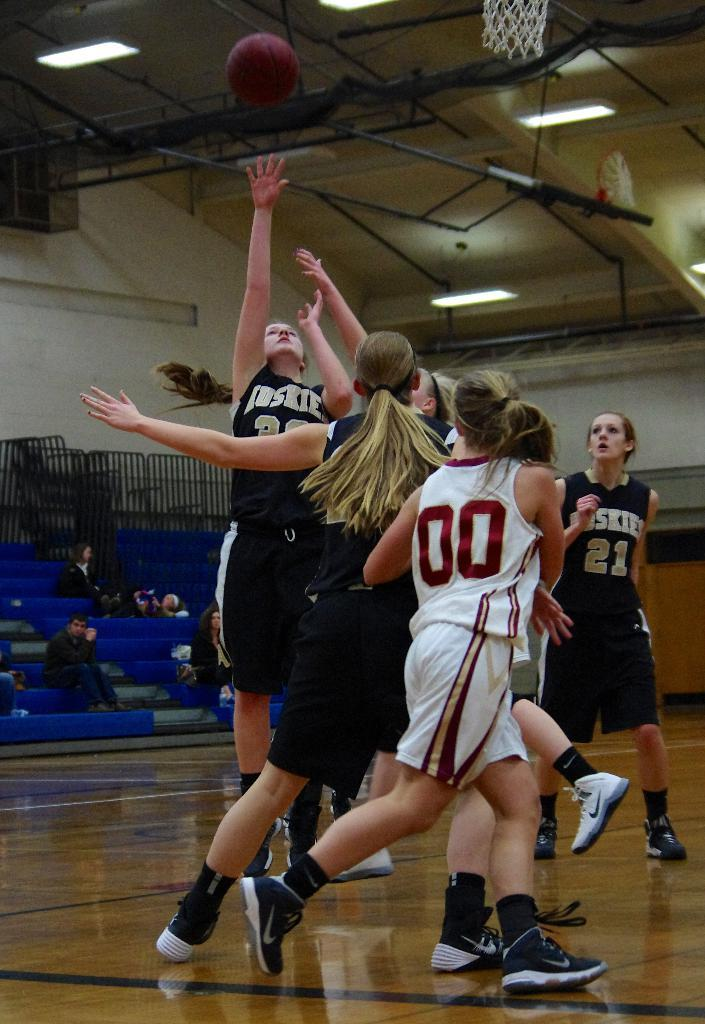<image>
Render a clear and concise summary of the photo. The girl is currently shooting the basketball is wearing a Huskies jersey 